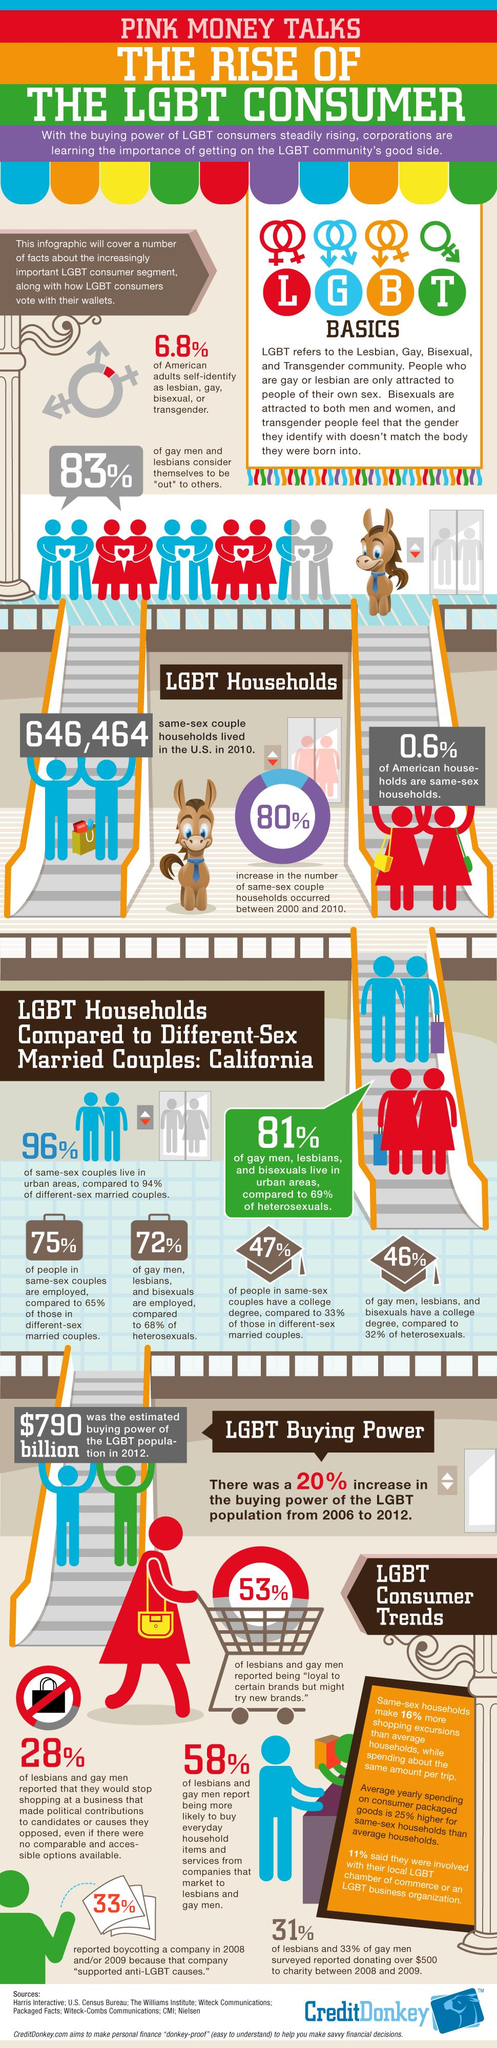Mention a couple of crucial points in this snapshot. According to data from 2000 and 2010, it was found that 80% of same-sex households increased during that time period. In California, approximately 47% of same-sex couples hold college degrees. A recent study found that 33% of LGBT individuals boycotted a company due to its anti-LGBT causes. According to a recent survey, 53% of gays and lesbians were found to be loyal to certain brands. 